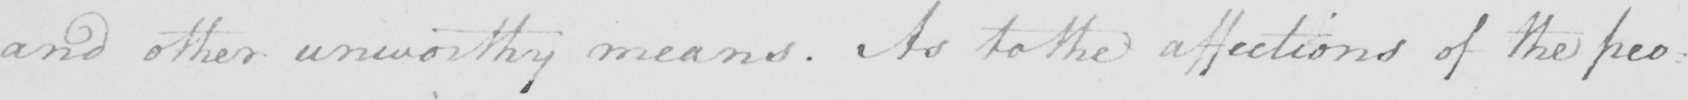What is written in this line of handwriting? and other unworthy means . As to the affections of the peo : 